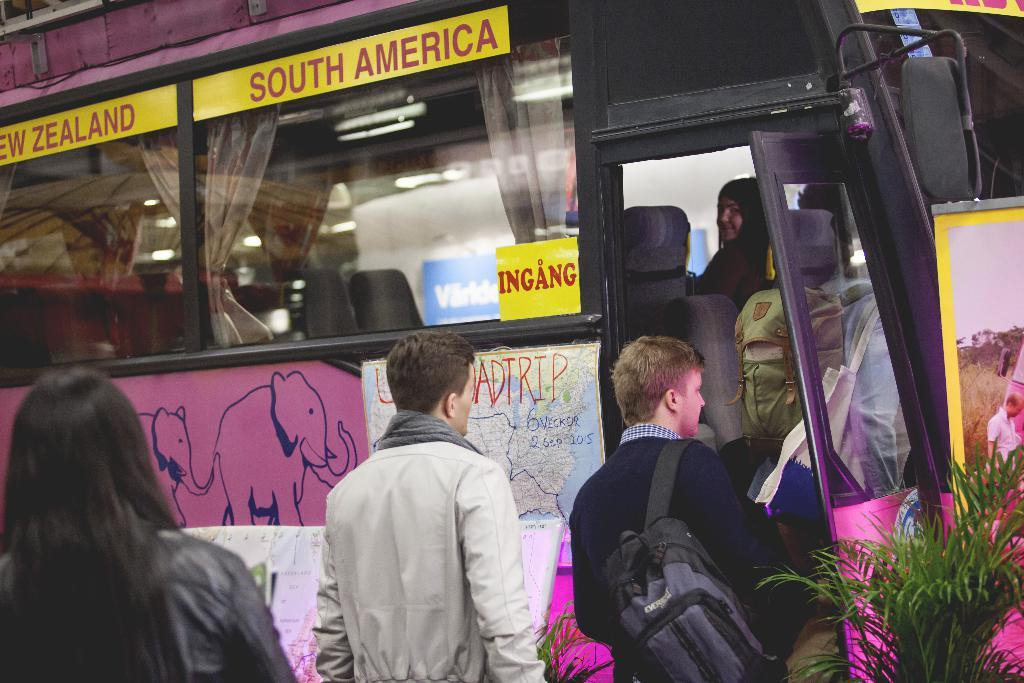Who or what can be seen in the image? There are people in the image. What else is present in the image besides people? There are plants, a vehicle, curtains, glass windows, and stickers attached to the vehicle. Can you describe the vehicle in the image? The vehicle has glass windows and stickers attached to it. What might be used for privacy or decoration in the vehicle? Curtains are present in the image for privacy or decoration. What type of corn is being served on the sofa in the image? There is no sofa or corn present in the image. What drink is being offered to the people in the vehicle? There is no drink being offered in the image; the focus is on the people, vehicle, and other visible items. 